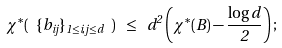<formula> <loc_0><loc_0><loc_500><loc_500>\chi ^ { * } ( \ \{ b _ { i j } \} _ { 1 \leq i , j \leq d } \ ) \ \leq \ d ^ { 2 } \left ( \chi ^ { * } ( B ) - \frac { \log d } { 2 } \right ) ;</formula> 